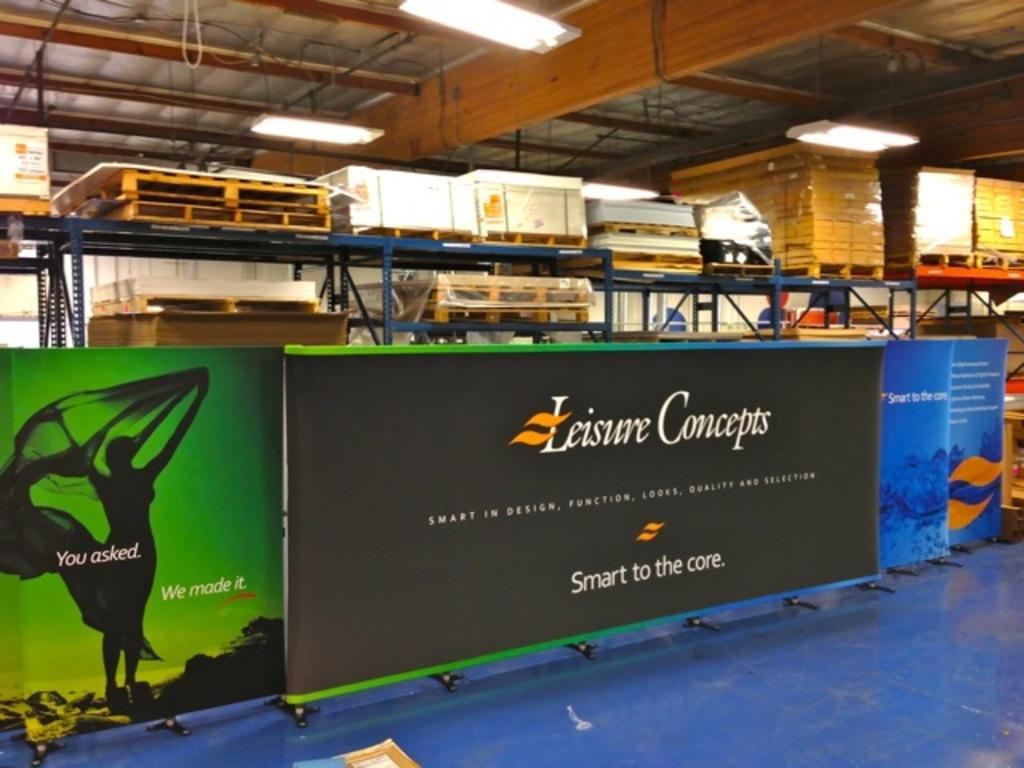<image>
Relay a brief, clear account of the picture shown. A Leisure Concepts billboard that Says "Smart to the core" is between two other billboards. 